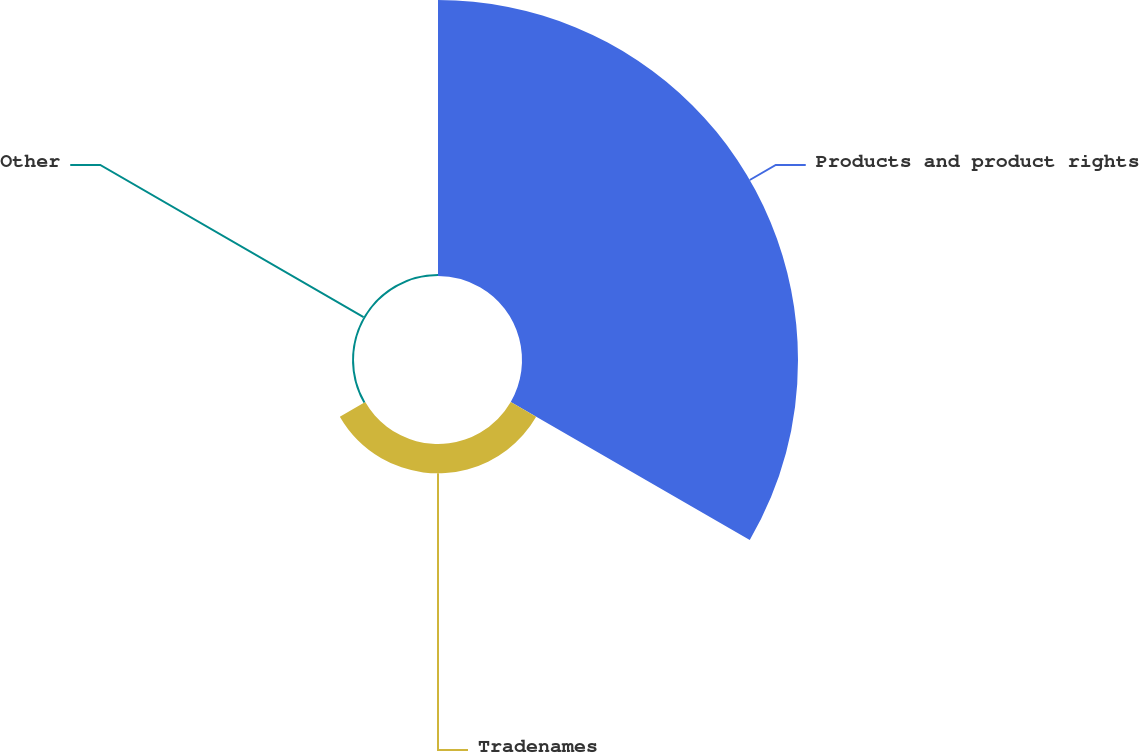Convert chart to OTSL. <chart><loc_0><loc_0><loc_500><loc_500><pie_chart><fcel>Products and product rights<fcel>Tradenames<fcel>Other<nl><fcel>89.81%<fcel>9.55%<fcel>0.64%<nl></chart> 